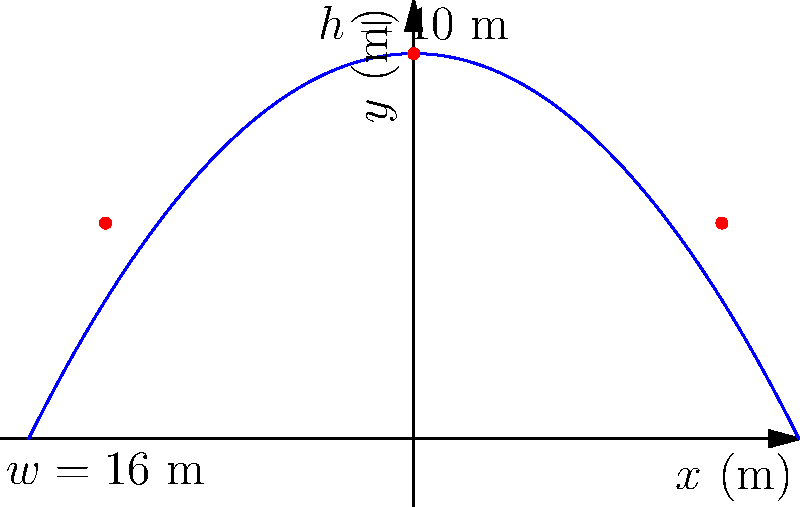As a documentary filmmaker exploring Prague's architectural wonders, you're analyzing the Gothic arches of Charles Bridge. The arch can be modeled by the parabolic function $f(x)=-0.1x^2+10$, where $x$ and $f(x)$ are measured in meters. The width of the arch is 16 meters. Calculate the load-bearing capacity of the arch in kN (kilonewtons) if it can support 5 kN per square meter of its area. To solve this problem, we'll follow these steps:

1) First, we need to find the area under the parabolic arch. This can be done using the integral:

   $$A = \int_{-8}^{8} (-0.1x^2 + 10) dx$$

2) Solve the integral:
   $$A = [-\frac{1}{30}x^3 + 10x]_{-8}^{8}$$
   $$A = (-\frac{1}{30}(8^3) + 10(8)) - (-\frac{1}{30}(-8^3) + 10(-8))$$
   $$A = (-17.07 + 80) - (17.07 - 80)$$
   $$A = 62.93 + 62.93 = 125.86 \text{ m}^2$$

3) Now that we have the area, we can calculate the load-bearing capacity:
   Load-bearing capacity = Area × Load per square meter
   $$\text{Capacity} = 125.86 \text{ m}^2 \times 5 \text{ kN/m}^2 = 629.3 \text{ kN}$$

Therefore, the load-bearing capacity of the arch is approximately 629.3 kN.
Answer: 629.3 kN 